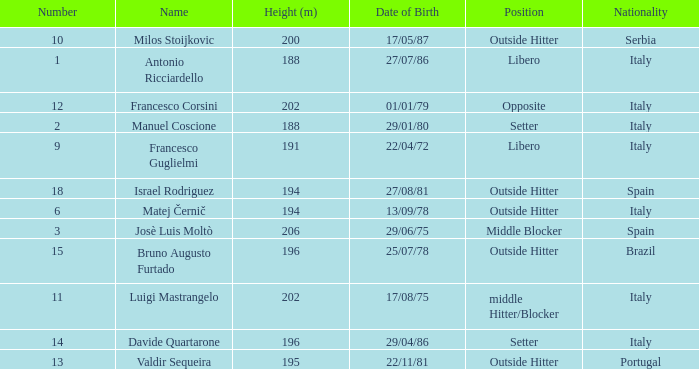Name the nationality for francesco guglielmi Italy. 